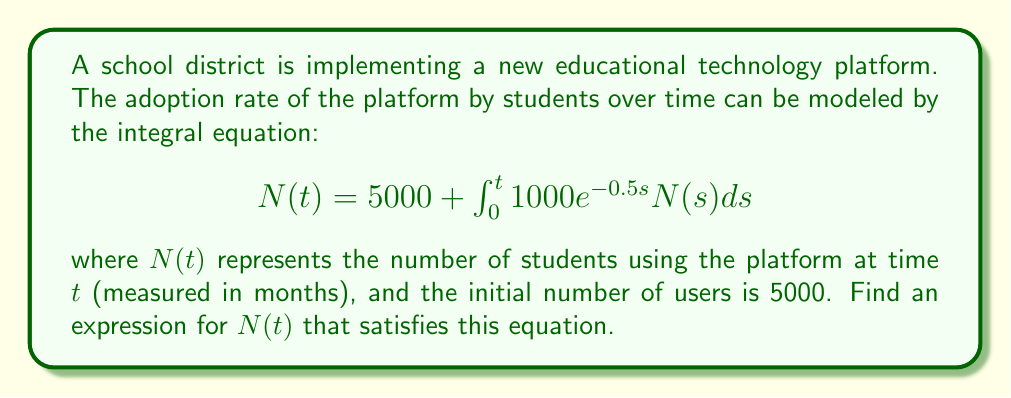Help me with this question. To solve this integral equation, we'll follow these steps:

1) First, we recognize this as a Volterra integral equation of the second kind.

2) We'll differentiate both sides with respect to $t$:

   $$\frac{d}{dt}N(t) = \frac{d}{dt}\left(5000 + \int_0^t 1000e^{-0.5s}N(s)ds\right)$$

3) Using the Fundamental Theorem of Calculus:

   $$N'(t) = 1000e^{-0.5t}N(t)$$

4) This is now a separable differential equation. We can rewrite it as:

   $$\frac{N'(t)}{N(t)} = 1000e^{-0.5t}$$

5) Integrate both sides:

   $$\int \frac{N'(t)}{N(t)}dt = \int 1000e^{-0.5t}dt$$

6) Solve the integrals:

   $$\ln|N(t)| = -2000e^{-0.5t} + C$$

7) Exponentiate both sides:

   $$N(t) = Ae^{-2000e^{-0.5t}}$$

   where $A$ is a constant.

8) To find $A$, use the initial condition $N(0) = 5000$:

   $$5000 = Ae^{-2000e^{-0.5(0)}} = Ae^{-2000}$$

   $$A = 5000e^{2000}$$

9) Therefore, the final solution is:

   $$N(t) = 5000e^{2000(1-e^{-0.5t})}$$

This expression satisfies the original integral equation and the initial condition.
Answer: $N(t) = 5000e^{2000(1-e^{-0.5t})}$ 